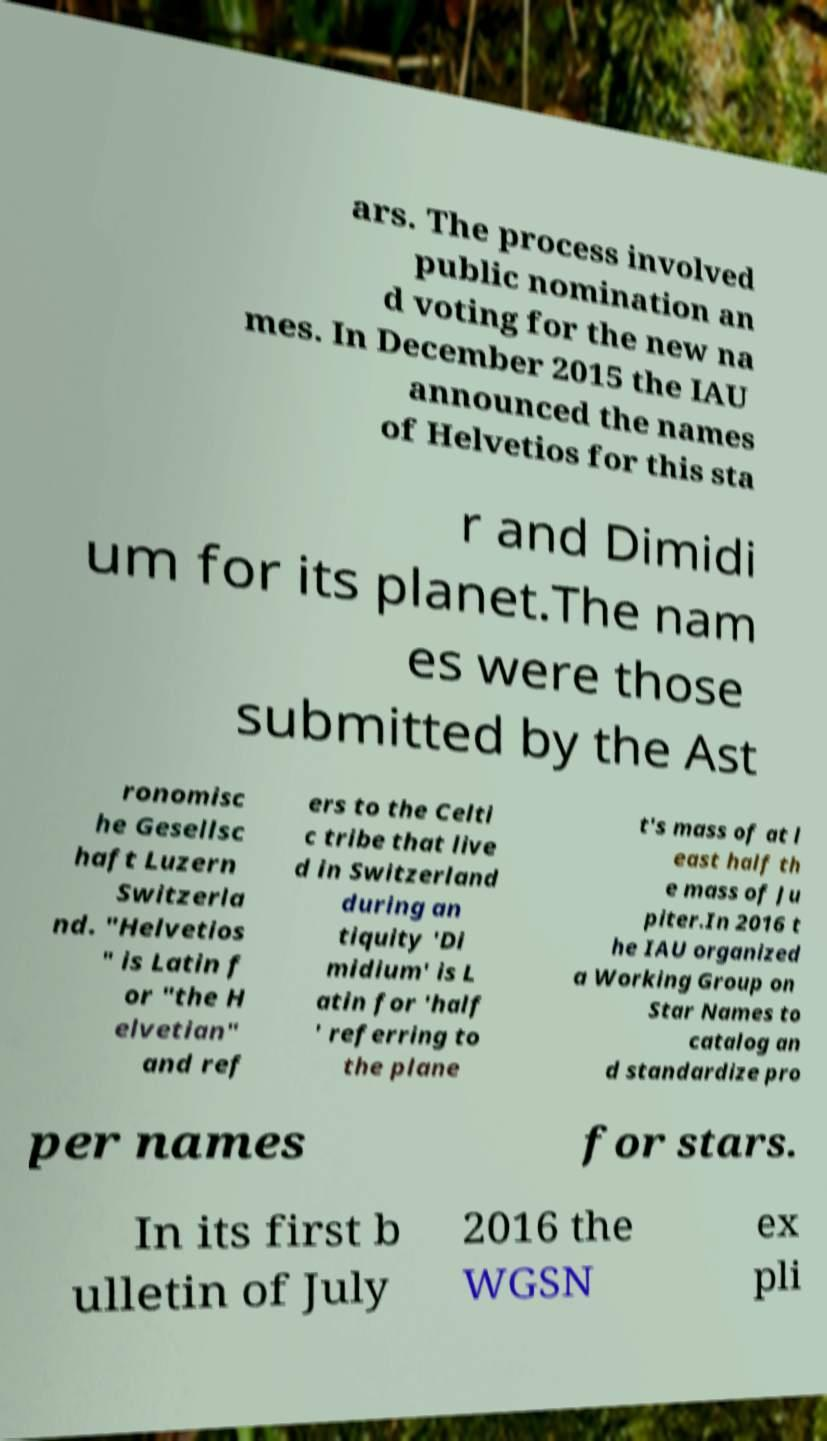For documentation purposes, I need the text within this image transcribed. Could you provide that? ars. The process involved public nomination an d voting for the new na mes. In December 2015 the IAU announced the names of Helvetios for this sta r and Dimidi um for its planet.The nam es were those submitted by the Ast ronomisc he Gesellsc haft Luzern Switzerla nd. "Helvetios " is Latin f or "the H elvetian" and ref ers to the Celti c tribe that live d in Switzerland during an tiquity 'Di midium' is L atin for 'half ' referring to the plane t's mass of at l east half th e mass of Ju piter.In 2016 t he IAU organized a Working Group on Star Names to catalog an d standardize pro per names for stars. In its first b ulletin of July 2016 the WGSN ex pli 